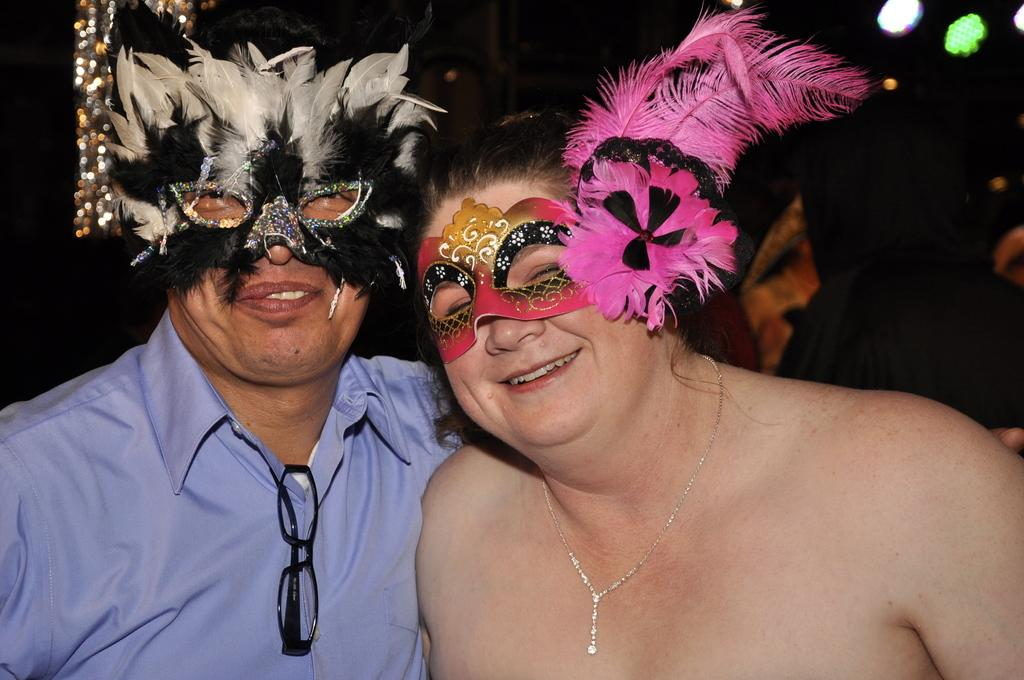Who is present in the image? There is a woman and a man in the image. What are the woman and the man wearing? They are both wearing decorative eye masks. What expressions do the woman and the man have? They are both smiling in the image. What are they doing in the image? They are giving a pose into the camera. What is the color of the background in the image? The background of the image is black. Can you tell me how many basketballs are visible in the image? There are no basketballs present in the image. What type of jewel is the woman wearing on her forehead in the image? There is no jewel visible on the woman's forehead in the image. 